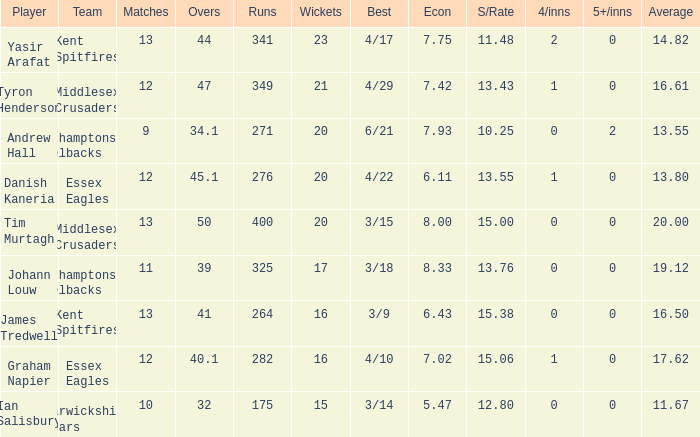Identify the minimum games for achieving 276 runs. 12.0. 